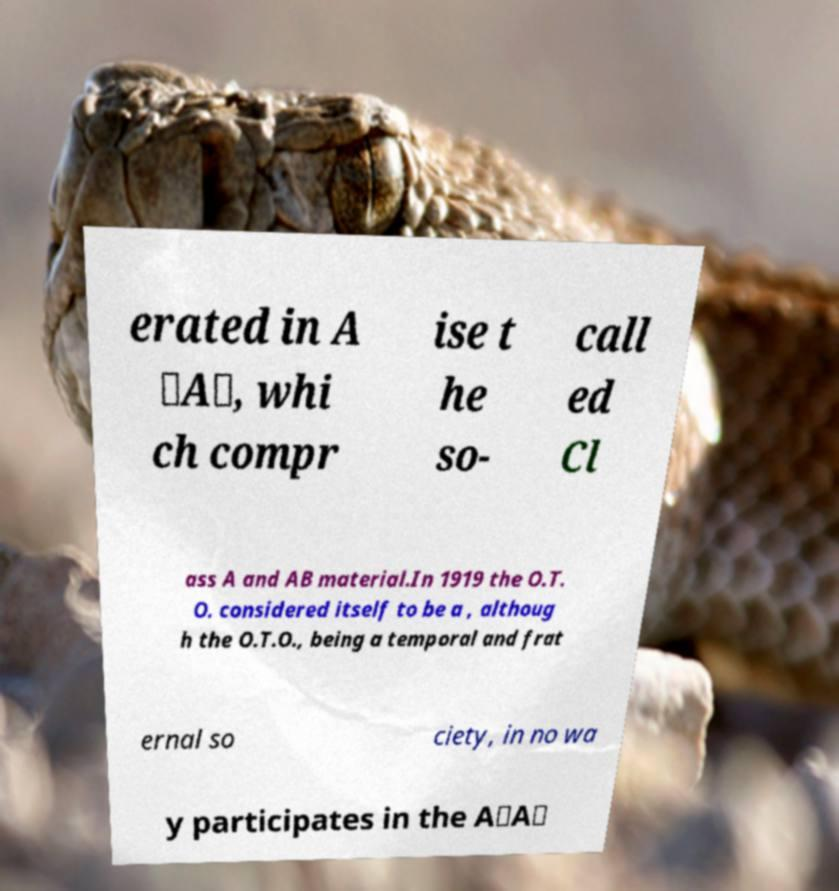For documentation purposes, I need the text within this image transcribed. Could you provide that? erated in A ∴A∴, whi ch compr ise t he so- call ed Cl ass A and AB material.In 1919 the O.T. O. considered itself to be a , althoug h the O.T.O., being a temporal and frat ernal so ciety, in no wa y participates in the A∴A∴ 